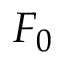<formula> <loc_0><loc_0><loc_500><loc_500>F _ { 0 }</formula> 